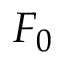<formula> <loc_0><loc_0><loc_500><loc_500>F _ { 0 }</formula> 